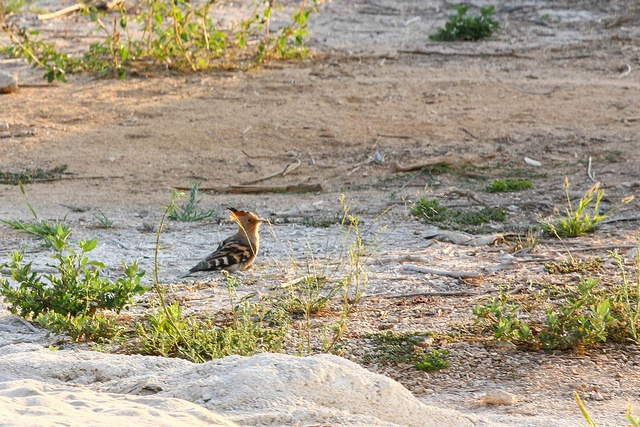Describe the objects in this image and their specific colors. I can see a bird in tan, black, gray, and maroon tones in this image. 